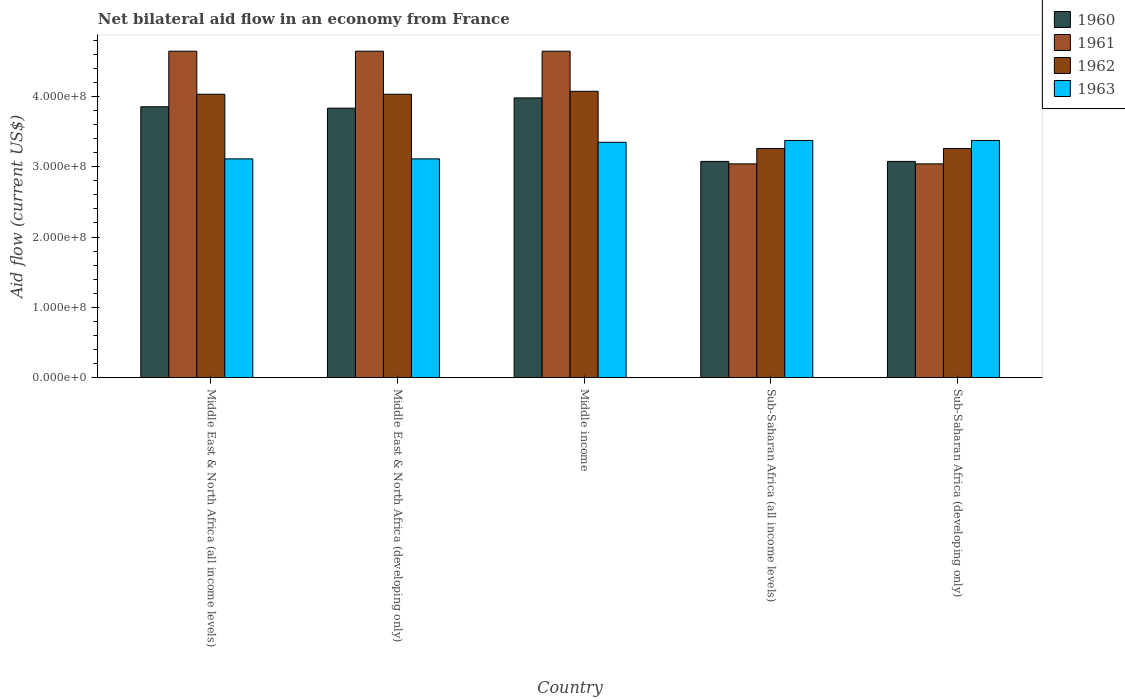How many different coloured bars are there?
Provide a short and direct response. 4. How many groups of bars are there?
Offer a terse response. 5. How many bars are there on the 4th tick from the left?
Give a very brief answer. 4. What is the net bilateral aid flow in 1962 in Middle East & North Africa (developing only)?
Your answer should be compact. 4.03e+08. Across all countries, what is the maximum net bilateral aid flow in 1963?
Provide a short and direct response. 3.37e+08. Across all countries, what is the minimum net bilateral aid flow in 1962?
Keep it short and to the point. 3.26e+08. In which country was the net bilateral aid flow in 1963 minimum?
Your answer should be compact. Middle East & North Africa (all income levels). What is the total net bilateral aid flow in 1960 in the graph?
Give a very brief answer. 1.78e+09. What is the difference between the net bilateral aid flow in 1960 in Middle East & North Africa (developing only) and that in Middle income?
Give a very brief answer. -1.46e+07. What is the difference between the net bilateral aid flow in 1962 in Middle income and the net bilateral aid flow in 1960 in Sub-Saharan Africa (all income levels)?
Make the answer very short. 9.97e+07. What is the average net bilateral aid flow in 1961 per country?
Provide a succinct answer. 4.00e+08. What is the difference between the net bilateral aid flow of/in 1960 and net bilateral aid flow of/in 1963 in Middle East & North Africa (developing only)?
Your answer should be very brief. 7.21e+07. What is the ratio of the net bilateral aid flow in 1962 in Sub-Saharan Africa (all income levels) to that in Sub-Saharan Africa (developing only)?
Offer a very short reply. 1. Is the difference between the net bilateral aid flow in 1960 in Middle East & North Africa (all income levels) and Sub-Saharan Africa (developing only) greater than the difference between the net bilateral aid flow in 1963 in Middle East & North Africa (all income levels) and Sub-Saharan Africa (developing only)?
Make the answer very short. Yes. What is the difference between the highest and the second highest net bilateral aid flow in 1960?
Provide a short and direct response. 1.46e+07. What is the difference between the highest and the lowest net bilateral aid flow in 1960?
Your response must be concise. 9.03e+07. Is the sum of the net bilateral aid flow in 1962 in Middle East & North Africa (all income levels) and Sub-Saharan Africa (all income levels) greater than the maximum net bilateral aid flow in 1961 across all countries?
Ensure brevity in your answer.  Yes. Is it the case that in every country, the sum of the net bilateral aid flow in 1963 and net bilateral aid flow in 1961 is greater than the sum of net bilateral aid flow in 1962 and net bilateral aid flow in 1960?
Keep it short and to the point. No. What does the 1st bar from the right in Middle East & North Africa (developing only) represents?
Your response must be concise. 1963. Is it the case that in every country, the sum of the net bilateral aid flow in 1961 and net bilateral aid flow in 1960 is greater than the net bilateral aid flow in 1963?
Offer a terse response. Yes. Are all the bars in the graph horizontal?
Provide a short and direct response. No. How many countries are there in the graph?
Your response must be concise. 5. Does the graph contain any zero values?
Provide a succinct answer. No. What is the title of the graph?
Your response must be concise. Net bilateral aid flow in an economy from France. Does "2003" appear as one of the legend labels in the graph?
Provide a succinct answer. No. What is the label or title of the X-axis?
Provide a succinct answer. Country. What is the label or title of the Y-axis?
Provide a short and direct response. Aid flow (current US$). What is the Aid flow (current US$) in 1960 in Middle East & North Africa (all income levels)?
Offer a very short reply. 3.85e+08. What is the Aid flow (current US$) in 1961 in Middle East & North Africa (all income levels)?
Provide a short and direct response. 4.64e+08. What is the Aid flow (current US$) in 1962 in Middle East & North Africa (all income levels)?
Ensure brevity in your answer.  4.03e+08. What is the Aid flow (current US$) in 1963 in Middle East & North Africa (all income levels)?
Offer a terse response. 3.11e+08. What is the Aid flow (current US$) in 1960 in Middle East & North Africa (developing only)?
Offer a very short reply. 3.83e+08. What is the Aid flow (current US$) in 1961 in Middle East & North Africa (developing only)?
Offer a terse response. 4.64e+08. What is the Aid flow (current US$) in 1962 in Middle East & North Africa (developing only)?
Offer a terse response. 4.03e+08. What is the Aid flow (current US$) in 1963 in Middle East & North Africa (developing only)?
Offer a very short reply. 3.11e+08. What is the Aid flow (current US$) in 1960 in Middle income?
Keep it short and to the point. 3.98e+08. What is the Aid flow (current US$) of 1961 in Middle income?
Provide a succinct answer. 4.64e+08. What is the Aid flow (current US$) of 1962 in Middle income?
Your answer should be compact. 4.07e+08. What is the Aid flow (current US$) in 1963 in Middle income?
Keep it short and to the point. 3.35e+08. What is the Aid flow (current US$) of 1960 in Sub-Saharan Africa (all income levels)?
Your answer should be compact. 3.08e+08. What is the Aid flow (current US$) of 1961 in Sub-Saharan Africa (all income levels)?
Offer a terse response. 3.04e+08. What is the Aid flow (current US$) in 1962 in Sub-Saharan Africa (all income levels)?
Offer a very short reply. 3.26e+08. What is the Aid flow (current US$) of 1963 in Sub-Saharan Africa (all income levels)?
Ensure brevity in your answer.  3.37e+08. What is the Aid flow (current US$) of 1960 in Sub-Saharan Africa (developing only)?
Ensure brevity in your answer.  3.08e+08. What is the Aid flow (current US$) of 1961 in Sub-Saharan Africa (developing only)?
Offer a very short reply. 3.04e+08. What is the Aid flow (current US$) in 1962 in Sub-Saharan Africa (developing only)?
Your answer should be compact. 3.26e+08. What is the Aid flow (current US$) of 1963 in Sub-Saharan Africa (developing only)?
Provide a short and direct response. 3.37e+08. Across all countries, what is the maximum Aid flow (current US$) in 1960?
Your answer should be very brief. 3.98e+08. Across all countries, what is the maximum Aid flow (current US$) in 1961?
Offer a terse response. 4.64e+08. Across all countries, what is the maximum Aid flow (current US$) of 1962?
Offer a very short reply. 4.07e+08. Across all countries, what is the maximum Aid flow (current US$) of 1963?
Give a very brief answer. 3.37e+08. Across all countries, what is the minimum Aid flow (current US$) in 1960?
Ensure brevity in your answer.  3.08e+08. Across all countries, what is the minimum Aid flow (current US$) of 1961?
Your response must be concise. 3.04e+08. Across all countries, what is the minimum Aid flow (current US$) of 1962?
Provide a short and direct response. 3.26e+08. Across all countries, what is the minimum Aid flow (current US$) in 1963?
Provide a short and direct response. 3.11e+08. What is the total Aid flow (current US$) of 1960 in the graph?
Provide a short and direct response. 1.78e+09. What is the total Aid flow (current US$) of 1961 in the graph?
Make the answer very short. 2.00e+09. What is the total Aid flow (current US$) of 1962 in the graph?
Your answer should be very brief. 1.86e+09. What is the total Aid flow (current US$) of 1963 in the graph?
Provide a short and direct response. 1.63e+09. What is the difference between the Aid flow (current US$) in 1963 in Middle East & North Africa (all income levels) and that in Middle East & North Africa (developing only)?
Make the answer very short. 0. What is the difference between the Aid flow (current US$) of 1960 in Middle East & North Africa (all income levels) and that in Middle income?
Keep it short and to the point. -1.26e+07. What is the difference between the Aid flow (current US$) in 1962 in Middle East & North Africa (all income levels) and that in Middle income?
Provide a succinct answer. -4.20e+06. What is the difference between the Aid flow (current US$) of 1963 in Middle East & North Africa (all income levels) and that in Middle income?
Make the answer very short. -2.36e+07. What is the difference between the Aid flow (current US$) of 1960 in Middle East & North Africa (all income levels) and that in Sub-Saharan Africa (all income levels)?
Make the answer very short. 7.77e+07. What is the difference between the Aid flow (current US$) of 1961 in Middle East & North Africa (all income levels) and that in Sub-Saharan Africa (all income levels)?
Provide a short and direct response. 1.60e+08. What is the difference between the Aid flow (current US$) of 1962 in Middle East & North Africa (all income levels) and that in Sub-Saharan Africa (all income levels)?
Keep it short and to the point. 7.71e+07. What is the difference between the Aid flow (current US$) of 1963 in Middle East & North Africa (all income levels) and that in Sub-Saharan Africa (all income levels)?
Ensure brevity in your answer.  -2.62e+07. What is the difference between the Aid flow (current US$) of 1960 in Middle East & North Africa (all income levels) and that in Sub-Saharan Africa (developing only)?
Provide a succinct answer. 7.77e+07. What is the difference between the Aid flow (current US$) in 1961 in Middle East & North Africa (all income levels) and that in Sub-Saharan Africa (developing only)?
Make the answer very short. 1.60e+08. What is the difference between the Aid flow (current US$) of 1962 in Middle East & North Africa (all income levels) and that in Sub-Saharan Africa (developing only)?
Provide a short and direct response. 7.71e+07. What is the difference between the Aid flow (current US$) in 1963 in Middle East & North Africa (all income levels) and that in Sub-Saharan Africa (developing only)?
Your answer should be compact. -2.62e+07. What is the difference between the Aid flow (current US$) in 1960 in Middle East & North Africa (developing only) and that in Middle income?
Make the answer very short. -1.46e+07. What is the difference between the Aid flow (current US$) in 1962 in Middle East & North Africa (developing only) and that in Middle income?
Give a very brief answer. -4.20e+06. What is the difference between the Aid flow (current US$) in 1963 in Middle East & North Africa (developing only) and that in Middle income?
Offer a very short reply. -2.36e+07. What is the difference between the Aid flow (current US$) of 1960 in Middle East & North Africa (developing only) and that in Sub-Saharan Africa (all income levels)?
Provide a succinct answer. 7.57e+07. What is the difference between the Aid flow (current US$) of 1961 in Middle East & North Africa (developing only) and that in Sub-Saharan Africa (all income levels)?
Make the answer very short. 1.60e+08. What is the difference between the Aid flow (current US$) of 1962 in Middle East & North Africa (developing only) and that in Sub-Saharan Africa (all income levels)?
Your answer should be very brief. 7.71e+07. What is the difference between the Aid flow (current US$) of 1963 in Middle East & North Africa (developing only) and that in Sub-Saharan Africa (all income levels)?
Provide a short and direct response. -2.62e+07. What is the difference between the Aid flow (current US$) in 1960 in Middle East & North Africa (developing only) and that in Sub-Saharan Africa (developing only)?
Ensure brevity in your answer.  7.57e+07. What is the difference between the Aid flow (current US$) of 1961 in Middle East & North Africa (developing only) and that in Sub-Saharan Africa (developing only)?
Provide a short and direct response. 1.60e+08. What is the difference between the Aid flow (current US$) in 1962 in Middle East & North Africa (developing only) and that in Sub-Saharan Africa (developing only)?
Give a very brief answer. 7.71e+07. What is the difference between the Aid flow (current US$) in 1963 in Middle East & North Africa (developing only) and that in Sub-Saharan Africa (developing only)?
Make the answer very short. -2.62e+07. What is the difference between the Aid flow (current US$) of 1960 in Middle income and that in Sub-Saharan Africa (all income levels)?
Provide a succinct answer. 9.03e+07. What is the difference between the Aid flow (current US$) of 1961 in Middle income and that in Sub-Saharan Africa (all income levels)?
Your response must be concise. 1.60e+08. What is the difference between the Aid flow (current US$) in 1962 in Middle income and that in Sub-Saharan Africa (all income levels)?
Your answer should be compact. 8.13e+07. What is the difference between the Aid flow (current US$) in 1963 in Middle income and that in Sub-Saharan Africa (all income levels)?
Give a very brief answer. -2.60e+06. What is the difference between the Aid flow (current US$) in 1960 in Middle income and that in Sub-Saharan Africa (developing only)?
Provide a succinct answer. 9.03e+07. What is the difference between the Aid flow (current US$) of 1961 in Middle income and that in Sub-Saharan Africa (developing only)?
Make the answer very short. 1.60e+08. What is the difference between the Aid flow (current US$) in 1962 in Middle income and that in Sub-Saharan Africa (developing only)?
Make the answer very short. 8.13e+07. What is the difference between the Aid flow (current US$) in 1963 in Middle income and that in Sub-Saharan Africa (developing only)?
Provide a succinct answer. -2.60e+06. What is the difference between the Aid flow (current US$) in 1960 in Sub-Saharan Africa (all income levels) and that in Sub-Saharan Africa (developing only)?
Provide a short and direct response. 0. What is the difference between the Aid flow (current US$) of 1960 in Middle East & North Africa (all income levels) and the Aid flow (current US$) of 1961 in Middle East & North Africa (developing only)?
Give a very brief answer. -7.90e+07. What is the difference between the Aid flow (current US$) of 1960 in Middle East & North Africa (all income levels) and the Aid flow (current US$) of 1962 in Middle East & North Africa (developing only)?
Make the answer very short. -1.78e+07. What is the difference between the Aid flow (current US$) of 1960 in Middle East & North Africa (all income levels) and the Aid flow (current US$) of 1963 in Middle East & North Africa (developing only)?
Give a very brief answer. 7.41e+07. What is the difference between the Aid flow (current US$) in 1961 in Middle East & North Africa (all income levels) and the Aid flow (current US$) in 1962 in Middle East & North Africa (developing only)?
Offer a terse response. 6.12e+07. What is the difference between the Aid flow (current US$) in 1961 in Middle East & North Africa (all income levels) and the Aid flow (current US$) in 1963 in Middle East & North Africa (developing only)?
Your response must be concise. 1.53e+08. What is the difference between the Aid flow (current US$) in 1962 in Middle East & North Africa (all income levels) and the Aid flow (current US$) in 1963 in Middle East & North Africa (developing only)?
Offer a terse response. 9.19e+07. What is the difference between the Aid flow (current US$) in 1960 in Middle East & North Africa (all income levels) and the Aid flow (current US$) in 1961 in Middle income?
Your answer should be compact. -7.90e+07. What is the difference between the Aid flow (current US$) of 1960 in Middle East & North Africa (all income levels) and the Aid flow (current US$) of 1962 in Middle income?
Give a very brief answer. -2.20e+07. What is the difference between the Aid flow (current US$) of 1960 in Middle East & North Africa (all income levels) and the Aid flow (current US$) of 1963 in Middle income?
Offer a terse response. 5.05e+07. What is the difference between the Aid flow (current US$) in 1961 in Middle East & North Africa (all income levels) and the Aid flow (current US$) in 1962 in Middle income?
Your answer should be compact. 5.70e+07. What is the difference between the Aid flow (current US$) in 1961 in Middle East & North Africa (all income levels) and the Aid flow (current US$) in 1963 in Middle income?
Your answer should be compact. 1.30e+08. What is the difference between the Aid flow (current US$) in 1962 in Middle East & North Africa (all income levels) and the Aid flow (current US$) in 1963 in Middle income?
Ensure brevity in your answer.  6.83e+07. What is the difference between the Aid flow (current US$) in 1960 in Middle East & North Africa (all income levels) and the Aid flow (current US$) in 1961 in Sub-Saharan Africa (all income levels)?
Keep it short and to the point. 8.12e+07. What is the difference between the Aid flow (current US$) in 1960 in Middle East & North Africa (all income levels) and the Aid flow (current US$) in 1962 in Sub-Saharan Africa (all income levels)?
Offer a very short reply. 5.93e+07. What is the difference between the Aid flow (current US$) in 1960 in Middle East & North Africa (all income levels) and the Aid flow (current US$) in 1963 in Sub-Saharan Africa (all income levels)?
Offer a very short reply. 4.79e+07. What is the difference between the Aid flow (current US$) of 1961 in Middle East & North Africa (all income levels) and the Aid flow (current US$) of 1962 in Sub-Saharan Africa (all income levels)?
Make the answer very short. 1.38e+08. What is the difference between the Aid flow (current US$) in 1961 in Middle East & North Africa (all income levels) and the Aid flow (current US$) in 1963 in Sub-Saharan Africa (all income levels)?
Give a very brief answer. 1.27e+08. What is the difference between the Aid flow (current US$) in 1962 in Middle East & North Africa (all income levels) and the Aid flow (current US$) in 1963 in Sub-Saharan Africa (all income levels)?
Provide a short and direct response. 6.57e+07. What is the difference between the Aid flow (current US$) of 1960 in Middle East & North Africa (all income levels) and the Aid flow (current US$) of 1961 in Sub-Saharan Africa (developing only)?
Offer a terse response. 8.12e+07. What is the difference between the Aid flow (current US$) in 1960 in Middle East & North Africa (all income levels) and the Aid flow (current US$) in 1962 in Sub-Saharan Africa (developing only)?
Keep it short and to the point. 5.93e+07. What is the difference between the Aid flow (current US$) in 1960 in Middle East & North Africa (all income levels) and the Aid flow (current US$) in 1963 in Sub-Saharan Africa (developing only)?
Keep it short and to the point. 4.79e+07. What is the difference between the Aid flow (current US$) in 1961 in Middle East & North Africa (all income levels) and the Aid flow (current US$) in 1962 in Sub-Saharan Africa (developing only)?
Offer a very short reply. 1.38e+08. What is the difference between the Aid flow (current US$) of 1961 in Middle East & North Africa (all income levels) and the Aid flow (current US$) of 1963 in Sub-Saharan Africa (developing only)?
Your answer should be very brief. 1.27e+08. What is the difference between the Aid flow (current US$) in 1962 in Middle East & North Africa (all income levels) and the Aid flow (current US$) in 1963 in Sub-Saharan Africa (developing only)?
Your answer should be compact. 6.57e+07. What is the difference between the Aid flow (current US$) in 1960 in Middle East & North Africa (developing only) and the Aid flow (current US$) in 1961 in Middle income?
Ensure brevity in your answer.  -8.10e+07. What is the difference between the Aid flow (current US$) in 1960 in Middle East & North Africa (developing only) and the Aid flow (current US$) in 1962 in Middle income?
Give a very brief answer. -2.40e+07. What is the difference between the Aid flow (current US$) of 1960 in Middle East & North Africa (developing only) and the Aid flow (current US$) of 1963 in Middle income?
Offer a terse response. 4.85e+07. What is the difference between the Aid flow (current US$) of 1961 in Middle East & North Africa (developing only) and the Aid flow (current US$) of 1962 in Middle income?
Offer a very short reply. 5.70e+07. What is the difference between the Aid flow (current US$) of 1961 in Middle East & North Africa (developing only) and the Aid flow (current US$) of 1963 in Middle income?
Offer a very short reply. 1.30e+08. What is the difference between the Aid flow (current US$) in 1962 in Middle East & North Africa (developing only) and the Aid flow (current US$) in 1963 in Middle income?
Keep it short and to the point. 6.83e+07. What is the difference between the Aid flow (current US$) of 1960 in Middle East & North Africa (developing only) and the Aid flow (current US$) of 1961 in Sub-Saharan Africa (all income levels)?
Give a very brief answer. 7.92e+07. What is the difference between the Aid flow (current US$) of 1960 in Middle East & North Africa (developing only) and the Aid flow (current US$) of 1962 in Sub-Saharan Africa (all income levels)?
Ensure brevity in your answer.  5.73e+07. What is the difference between the Aid flow (current US$) in 1960 in Middle East & North Africa (developing only) and the Aid flow (current US$) in 1963 in Sub-Saharan Africa (all income levels)?
Ensure brevity in your answer.  4.59e+07. What is the difference between the Aid flow (current US$) in 1961 in Middle East & North Africa (developing only) and the Aid flow (current US$) in 1962 in Sub-Saharan Africa (all income levels)?
Your response must be concise. 1.38e+08. What is the difference between the Aid flow (current US$) of 1961 in Middle East & North Africa (developing only) and the Aid flow (current US$) of 1963 in Sub-Saharan Africa (all income levels)?
Your response must be concise. 1.27e+08. What is the difference between the Aid flow (current US$) of 1962 in Middle East & North Africa (developing only) and the Aid flow (current US$) of 1963 in Sub-Saharan Africa (all income levels)?
Offer a very short reply. 6.57e+07. What is the difference between the Aid flow (current US$) in 1960 in Middle East & North Africa (developing only) and the Aid flow (current US$) in 1961 in Sub-Saharan Africa (developing only)?
Provide a succinct answer. 7.92e+07. What is the difference between the Aid flow (current US$) in 1960 in Middle East & North Africa (developing only) and the Aid flow (current US$) in 1962 in Sub-Saharan Africa (developing only)?
Give a very brief answer. 5.73e+07. What is the difference between the Aid flow (current US$) in 1960 in Middle East & North Africa (developing only) and the Aid flow (current US$) in 1963 in Sub-Saharan Africa (developing only)?
Offer a very short reply. 4.59e+07. What is the difference between the Aid flow (current US$) of 1961 in Middle East & North Africa (developing only) and the Aid flow (current US$) of 1962 in Sub-Saharan Africa (developing only)?
Your response must be concise. 1.38e+08. What is the difference between the Aid flow (current US$) of 1961 in Middle East & North Africa (developing only) and the Aid flow (current US$) of 1963 in Sub-Saharan Africa (developing only)?
Provide a succinct answer. 1.27e+08. What is the difference between the Aid flow (current US$) in 1962 in Middle East & North Africa (developing only) and the Aid flow (current US$) in 1963 in Sub-Saharan Africa (developing only)?
Your answer should be compact. 6.57e+07. What is the difference between the Aid flow (current US$) of 1960 in Middle income and the Aid flow (current US$) of 1961 in Sub-Saharan Africa (all income levels)?
Offer a terse response. 9.38e+07. What is the difference between the Aid flow (current US$) in 1960 in Middle income and the Aid flow (current US$) in 1962 in Sub-Saharan Africa (all income levels)?
Ensure brevity in your answer.  7.19e+07. What is the difference between the Aid flow (current US$) of 1960 in Middle income and the Aid flow (current US$) of 1963 in Sub-Saharan Africa (all income levels)?
Your answer should be very brief. 6.05e+07. What is the difference between the Aid flow (current US$) in 1961 in Middle income and the Aid flow (current US$) in 1962 in Sub-Saharan Africa (all income levels)?
Your response must be concise. 1.38e+08. What is the difference between the Aid flow (current US$) of 1961 in Middle income and the Aid flow (current US$) of 1963 in Sub-Saharan Africa (all income levels)?
Give a very brief answer. 1.27e+08. What is the difference between the Aid flow (current US$) in 1962 in Middle income and the Aid flow (current US$) in 1963 in Sub-Saharan Africa (all income levels)?
Give a very brief answer. 6.99e+07. What is the difference between the Aid flow (current US$) in 1960 in Middle income and the Aid flow (current US$) in 1961 in Sub-Saharan Africa (developing only)?
Keep it short and to the point. 9.38e+07. What is the difference between the Aid flow (current US$) of 1960 in Middle income and the Aid flow (current US$) of 1962 in Sub-Saharan Africa (developing only)?
Your answer should be very brief. 7.19e+07. What is the difference between the Aid flow (current US$) in 1960 in Middle income and the Aid flow (current US$) in 1963 in Sub-Saharan Africa (developing only)?
Keep it short and to the point. 6.05e+07. What is the difference between the Aid flow (current US$) in 1961 in Middle income and the Aid flow (current US$) in 1962 in Sub-Saharan Africa (developing only)?
Offer a terse response. 1.38e+08. What is the difference between the Aid flow (current US$) of 1961 in Middle income and the Aid flow (current US$) of 1963 in Sub-Saharan Africa (developing only)?
Ensure brevity in your answer.  1.27e+08. What is the difference between the Aid flow (current US$) of 1962 in Middle income and the Aid flow (current US$) of 1963 in Sub-Saharan Africa (developing only)?
Your answer should be very brief. 6.99e+07. What is the difference between the Aid flow (current US$) of 1960 in Sub-Saharan Africa (all income levels) and the Aid flow (current US$) of 1961 in Sub-Saharan Africa (developing only)?
Offer a very short reply. 3.50e+06. What is the difference between the Aid flow (current US$) in 1960 in Sub-Saharan Africa (all income levels) and the Aid flow (current US$) in 1962 in Sub-Saharan Africa (developing only)?
Make the answer very short. -1.84e+07. What is the difference between the Aid flow (current US$) of 1960 in Sub-Saharan Africa (all income levels) and the Aid flow (current US$) of 1963 in Sub-Saharan Africa (developing only)?
Provide a succinct answer. -2.98e+07. What is the difference between the Aid flow (current US$) in 1961 in Sub-Saharan Africa (all income levels) and the Aid flow (current US$) in 1962 in Sub-Saharan Africa (developing only)?
Offer a terse response. -2.19e+07. What is the difference between the Aid flow (current US$) of 1961 in Sub-Saharan Africa (all income levels) and the Aid flow (current US$) of 1963 in Sub-Saharan Africa (developing only)?
Give a very brief answer. -3.33e+07. What is the difference between the Aid flow (current US$) of 1962 in Sub-Saharan Africa (all income levels) and the Aid flow (current US$) of 1963 in Sub-Saharan Africa (developing only)?
Make the answer very short. -1.14e+07. What is the average Aid flow (current US$) of 1960 per country?
Keep it short and to the point. 3.56e+08. What is the average Aid flow (current US$) of 1961 per country?
Your answer should be compact. 4.00e+08. What is the average Aid flow (current US$) of 1962 per country?
Your response must be concise. 3.73e+08. What is the average Aid flow (current US$) of 1963 per country?
Keep it short and to the point. 3.26e+08. What is the difference between the Aid flow (current US$) in 1960 and Aid flow (current US$) in 1961 in Middle East & North Africa (all income levels)?
Your answer should be very brief. -7.90e+07. What is the difference between the Aid flow (current US$) in 1960 and Aid flow (current US$) in 1962 in Middle East & North Africa (all income levels)?
Give a very brief answer. -1.78e+07. What is the difference between the Aid flow (current US$) of 1960 and Aid flow (current US$) of 1963 in Middle East & North Africa (all income levels)?
Provide a short and direct response. 7.41e+07. What is the difference between the Aid flow (current US$) of 1961 and Aid flow (current US$) of 1962 in Middle East & North Africa (all income levels)?
Your response must be concise. 6.12e+07. What is the difference between the Aid flow (current US$) of 1961 and Aid flow (current US$) of 1963 in Middle East & North Africa (all income levels)?
Your response must be concise. 1.53e+08. What is the difference between the Aid flow (current US$) of 1962 and Aid flow (current US$) of 1963 in Middle East & North Africa (all income levels)?
Keep it short and to the point. 9.19e+07. What is the difference between the Aid flow (current US$) in 1960 and Aid flow (current US$) in 1961 in Middle East & North Africa (developing only)?
Offer a terse response. -8.10e+07. What is the difference between the Aid flow (current US$) of 1960 and Aid flow (current US$) of 1962 in Middle East & North Africa (developing only)?
Provide a succinct answer. -1.98e+07. What is the difference between the Aid flow (current US$) of 1960 and Aid flow (current US$) of 1963 in Middle East & North Africa (developing only)?
Give a very brief answer. 7.21e+07. What is the difference between the Aid flow (current US$) in 1961 and Aid flow (current US$) in 1962 in Middle East & North Africa (developing only)?
Your answer should be compact. 6.12e+07. What is the difference between the Aid flow (current US$) in 1961 and Aid flow (current US$) in 1963 in Middle East & North Africa (developing only)?
Keep it short and to the point. 1.53e+08. What is the difference between the Aid flow (current US$) of 1962 and Aid flow (current US$) of 1963 in Middle East & North Africa (developing only)?
Make the answer very short. 9.19e+07. What is the difference between the Aid flow (current US$) in 1960 and Aid flow (current US$) in 1961 in Middle income?
Your answer should be very brief. -6.64e+07. What is the difference between the Aid flow (current US$) of 1960 and Aid flow (current US$) of 1962 in Middle income?
Provide a succinct answer. -9.40e+06. What is the difference between the Aid flow (current US$) of 1960 and Aid flow (current US$) of 1963 in Middle income?
Provide a succinct answer. 6.31e+07. What is the difference between the Aid flow (current US$) in 1961 and Aid flow (current US$) in 1962 in Middle income?
Offer a very short reply. 5.70e+07. What is the difference between the Aid flow (current US$) in 1961 and Aid flow (current US$) in 1963 in Middle income?
Keep it short and to the point. 1.30e+08. What is the difference between the Aid flow (current US$) in 1962 and Aid flow (current US$) in 1963 in Middle income?
Provide a short and direct response. 7.25e+07. What is the difference between the Aid flow (current US$) in 1960 and Aid flow (current US$) in 1961 in Sub-Saharan Africa (all income levels)?
Make the answer very short. 3.50e+06. What is the difference between the Aid flow (current US$) of 1960 and Aid flow (current US$) of 1962 in Sub-Saharan Africa (all income levels)?
Ensure brevity in your answer.  -1.84e+07. What is the difference between the Aid flow (current US$) in 1960 and Aid flow (current US$) in 1963 in Sub-Saharan Africa (all income levels)?
Your response must be concise. -2.98e+07. What is the difference between the Aid flow (current US$) in 1961 and Aid flow (current US$) in 1962 in Sub-Saharan Africa (all income levels)?
Provide a succinct answer. -2.19e+07. What is the difference between the Aid flow (current US$) in 1961 and Aid flow (current US$) in 1963 in Sub-Saharan Africa (all income levels)?
Make the answer very short. -3.33e+07. What is the difference between the Aid flow (current US$) in 1962 and Aid flow (current US$) in 1963 in Sub-Saharan Africa (all income levels)?
Make the answer very short. -1.14e+07. What is the difference between the Aid flow (current US$) of 1960 and Aid flow (current US$) of 1961 in Sub-Saharan Africa (developing only)?
Ensure brevity in your answer.  3.50e+06. What is the difference between the Aid flow (current US$) of 1960 and Aid flow (current US$) of 1962 in Sub-Saharan Africa (developing only)?
Make the answer very short. -1.84e+07. What is the difference between the Aid flow (current US$) of 1960 and Aid flow (current US$) of 1963 in Sub-Saharan Africa (developing only)?
Make the answer very short. -2.98e+07. What is the difference between the Aid flow (current US$) of 1961 and Aid flow (current US$) of 1962 in Sub-Saharan Africa (developing only)?
Make the answer very short. -2.19e+07. What is the difference between the Aid flow (current US$) in 1961 and Aid flow (current US$) in 1963 in Sub-Saharan Africa (developing only)?
Your answer should be compact. -3.33e+07. What is the difference between the Aid flow (current US$) of 1962 and Aid flow (current US$) of 1963 in Sub-Saharan Africa (developing only)?
Ensure brevity in your answer.  -1.14e+07. What is the ratio of the Aid flow (current US$) in 1961 in Middle East & North Africa (all income levels) to that in Middle East & North Africa (developing only)?
Provide a succinct answer. 1. What is the ratio of the Aid flow (current US$) of 1962 in Middle East & North Africa (all income levels) to that in Middle East & North Africa (developing only)?
Give a very brief answer. 1. What is the ratio of the Aid flow (current US$) in 1963 in Middle East & North Africa (all income levels) to that in Middle East & North Africa (developing only)?
Give a very brief answer. 1. What is the ratio of the Aid flow (current US$) in 1960 in Middle East & North Africa (all income levels) to that in Middle income?
Offer a terse response. 0.97. What is the ratio of the Aid flow (current US$) of 1962 in Middle East & North Africa (all income levels) to that in Middle income?
Offer a very short reply. 0.99. What is the ratio of the Aid flow (current US$) in 1963 in Middle East & North Africa (all income levels) to that in Middle income?
Give a very brief answer. 0.93. What is the ratio of the Aid flow (current US$) in 1960 in Middle East & North Africa (all income levels) to that in Sub-Saharan Africa (all income levels)?
Your answer should be compact. 1.25. What is the ratio of the Aid flow (current US$) of 1961 in Middle East & North Africa (all income levels) to that in Sub-Saharan Africa (all income levels)?
Provide a succinct answer. 1.53. What is the ratio of the Aid flow (current US$) in 1962 in Middle East & North Africa (all income levels) to that in Sub-Saharan Africa (all income levels)?
Your answer should be compact. 1.24. What is the ratio of the Aid flow (current US$) in 1963 in Middle East & North Africa (all income levels) to that in Sub-Saharan Africa (all income levels)?
Keep it short and to the point. 0.92. What is the ratio of the Aid flow (current US$) of 1960 in Middle East & North Africa (all income levels) to that in Sub-Saharan Africa (developing only)?
Give a very brief answer. 1.25. What is the ratio of the Aid flow (current US$) of 1961 in Middle East & North Africa (all income levels) to that in Sub-Saharan Africa (developing only)?
Ensure brevity in your answer.  1.53. What is the ratio of the Aid flow (current US$) in 1962 in Middle East & North Africa (all income levels) to that in Sub-Saharan Africa (developing only)?
Give a very brief answer. 1.24. What is the ratio of the Aid flow (current US$) in 1963 in Middle East & North Africa (all income levels) to that in Sub-Saharan Africa (developing only)?
Give a very brief answer. 0.92. What is the ratio of the Aid flow (current US$) in 1960 in Middle East & North Africa (developing only) to that in Middle income?
Your answer should be compact. 0.96. What is the ratio of the Aid flow (current US$) of 1962 in Middle East & North Africa (developing only) to that in Middle income?
Make the answer very short. 0.99. What is the ratio of the Aid flow (current US$) of 1963 in Middle East & North Africa (developing only) to that in Middle income?
Make the answer very short. 0.93. What is the ratio of the Aid flow (current US$) of 1960 in Middle East & North Africa (developing only) to that in Sub-Saharan Africa (all income levels)?
Your response must be concise. 1.25. What is the ratio of the Aid flow (current US$) of 1961 in Middle East & North Africa (developing only) to that in Sub-Saharan Africa (all income levels)?
Provide a short and direct response. 1.53. What is the ratio of the Aid flow (current US$) in 1962 in Middle East & North Africa (developing only) to that in Sub-Saharan Africa (all income levels)?
Your response must be concise. 1.24. What is the ratio of the Aid flow (current US$) in 1963 in Middle East & North Africa (developing only) to that in Sub-Saharan Africa (all income levels)?
Your response must be concise. 0.92. What is the ratio of the Aid flow (current US$) in 1960 in Middle East & North Africa (developing only) to that in Sub-Saharan Africa (developing only)?
Your answer should be very brief. 1.25. What is the ratio of the Aid flow (current US$) in 1961 in Middle East & North Africa (developing only) to that in Sub-Saharan Africa (developing only)?
Your answer should be compact. 1.53. What is the ratio of the Aid flow (current US$) of 1962 in Middle East & North Africa (developing only) to that in Sub-Saharan Africa (developing only)?
Your response must be concise. 1.24. What is the ratio of the Aid flow (current US$) of 1963 in Middle East & North Africa (developing only) to that in Sub-Saharan Africa (developing only)?
Provide a succinct answer. 0.92. What is the ratio of the Aid flow (current US$) of 1960 in Middle income to that in Sub-Saharan Africa (all income levels)?
Provide a short and direct response. 1.29. What is the ratio of the Aid flow (current US$) in 1961 in Middle income to that in Sub-Saharan Africa (all income levels)?
Keep it short and to the point. 1.53. What is the ratio of the Aid flow (current US$) in 1962 in Middle income to that in Sub-Saharan Africa (all income levels)?
Your answer should be compact. 1.25. What is the ratio of the Aid flow (current US$) in 1963 in Middle income to that in Sub-Saharan Africa (all income levels)?
Offer a very short reply. 0.99. What is the ratio of the Aid flow (current US$) in 1960 in Middle income to that in Sub-Saharan Africa (developing only)?
Make the answer very short. 1.29. What is the ratio of the Aid flow (current US$) of 1961 in Middle income to that in Sub-Saharan Africa (developing only)?
Your answer should be very brief. 1.53. What is the ratio of the Aid flow (current US$) of 1962 in Middle income to that in Sub-Saharan Africa (developing only)?
Keep it short and to the point. 1.25. What is the ratio of the Aid flow (current US$) of 1961 in Sub-Saharan Africa (all income levels) to that in Sub-Saharan Africa (developing only)?
Ensure brevity in your answer.  1. What is the ratio of the Aid flow (current US$) of 1962 in Sub-Saharan Africa (all income levels) to that in Sub-Saharan Africa (developing only)?
Make the answer very short. 1. What is the difference between the highest and the second highest Aid flow (current US$) in 1960?
Your response must be concise. 1.26e+07. What is the difference between the highest and the second highest Aid flow (current US$) in 1962?
Provide a short and direct response. 4.20e+06. What is the difference between the highest and the lowest Aid flow (current US$) in 1960?
Offer a very short reply. 9.03e+07. What is the difference between the highest and the lowest Aid flow (current US$) in 1961?
Offer a terse response. 1.60e+08. What is the difference between the highest and the lowest Aid flow (current US$) of 1962?
Provide a short and direct response. 8.13e+07. What is the difference between the highest and the lowest Aid flow (current US$) in 1963?
Your response must be concise. 2.62e+07. 